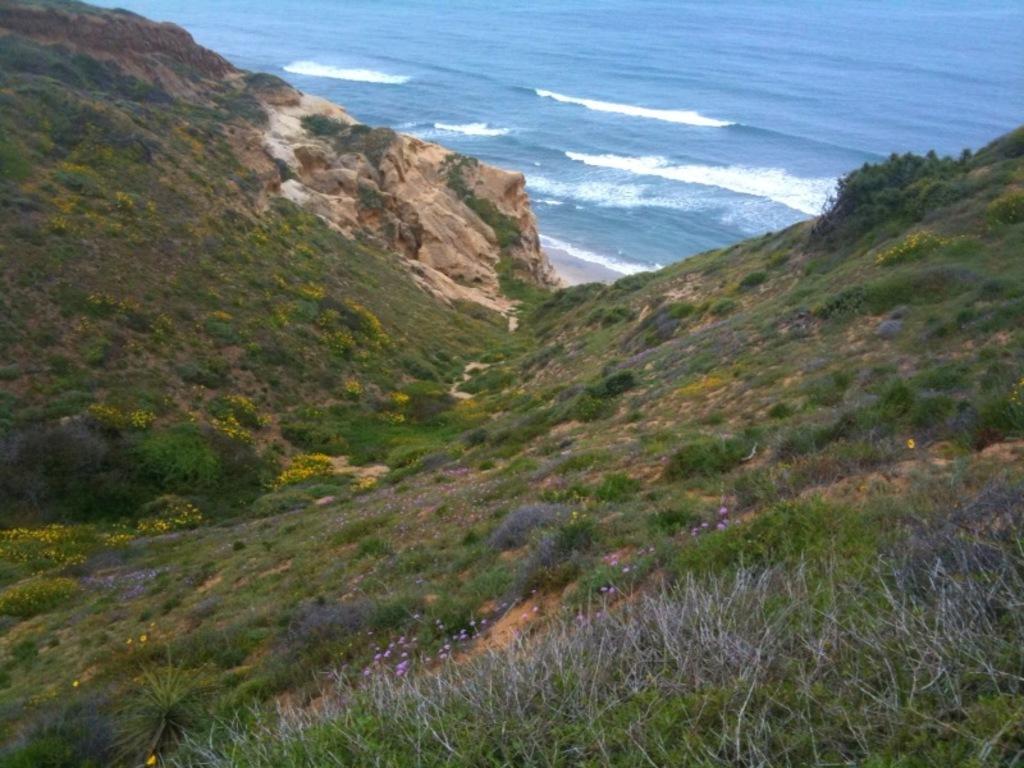Describe this image in one or two sentences. This picture is taken from outside of the city. In this image, we can see some trees, plants, flowers, grass and rocks. In the background, we can see water in an ocean. 